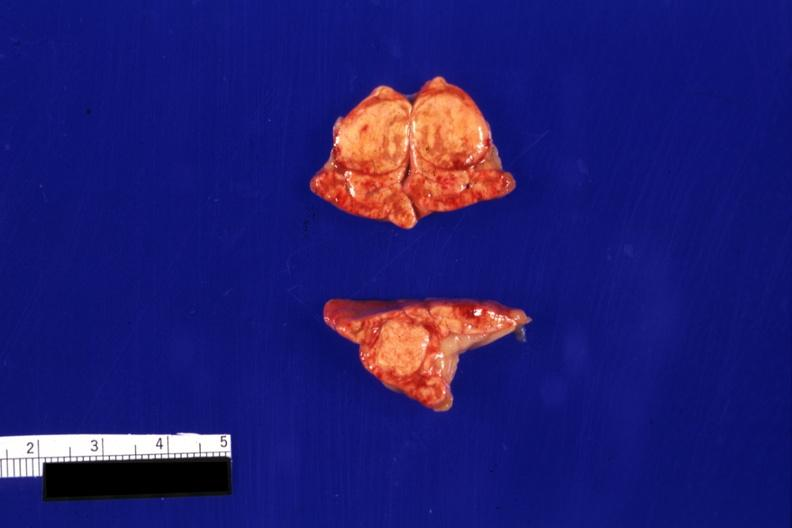what is present?
Answer the question using a single word or phrase. Adrenal 